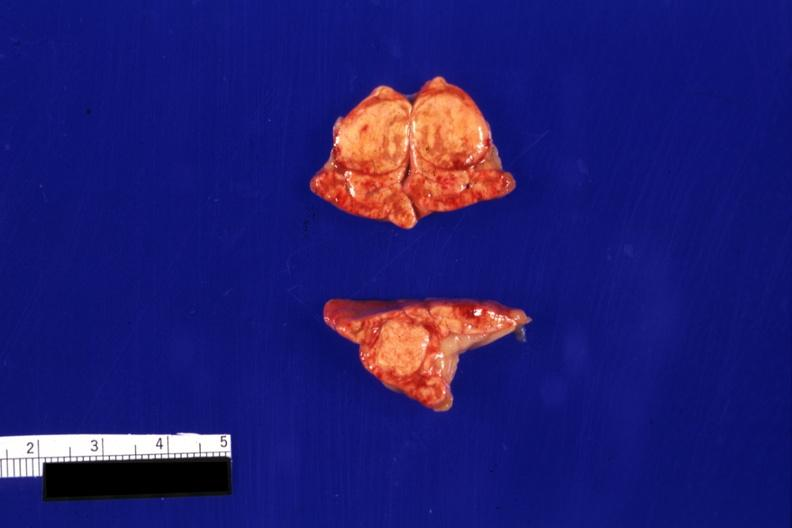what is present?
Answer the question using a single word or phrase. Adrenal 